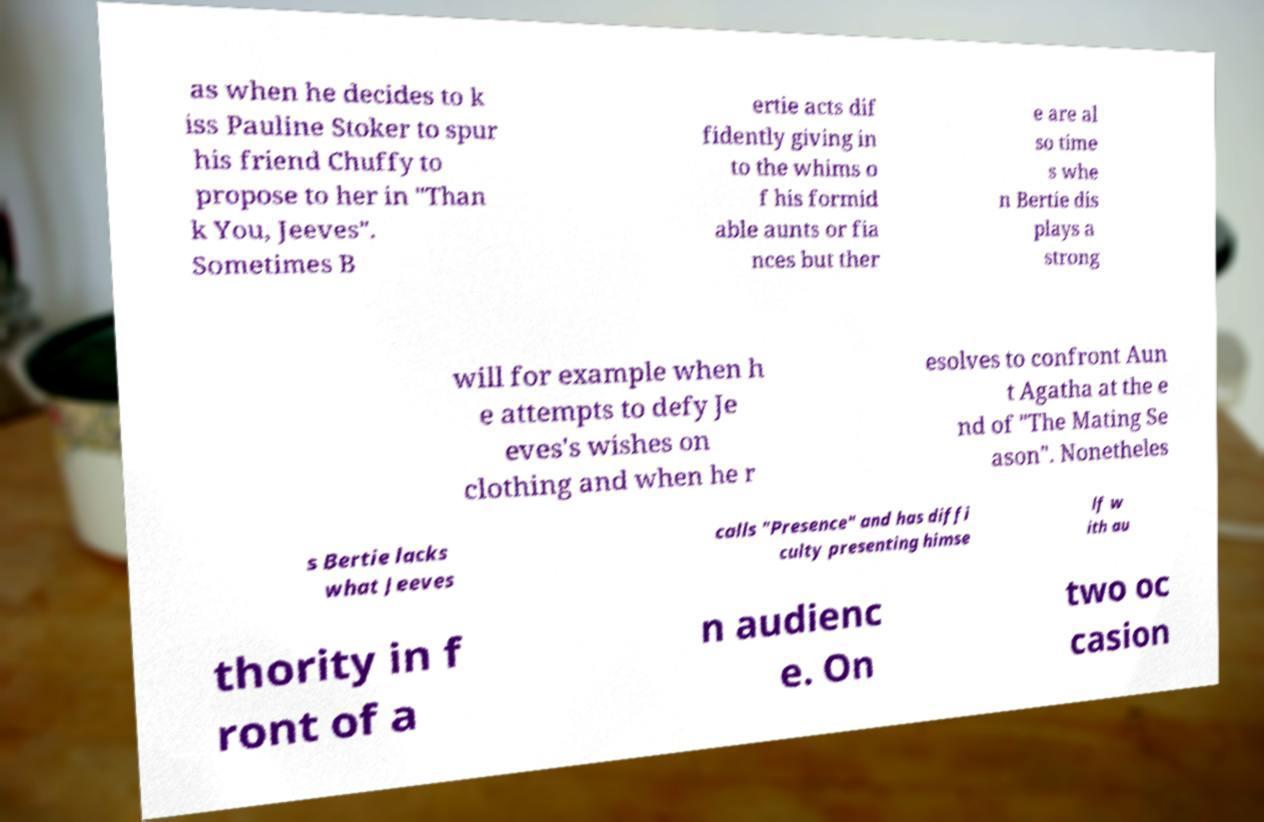Please read and relay the text visible in this image. What does it say? as when he decides to k iss Pauline Stoker to spur his friend Chuffy to propose to her in "Than k You, Jeeves". Sometimes B ertie acts dif fidently giving in to the whims o f his formid able aunts or fia nces but ther e are al so time s whe n Bertie dis plays a strong will for example when h e attempts to defy Je eves's wishes on clothing and when he r esolves to confront Aun t Agatha at the e nd of "The Mating Se ason". Nonetheles s Bertie lacks what Jeeves calls "Presence" and has diffi culty presenting himse lf w ith au thority in f ront of a n audienc e. On two oc casion 